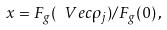<formula> <loc_0><loc_0><loc_500><loc_500>x = F _ { g } ( \ V e c { \rho } _ { j } ) / F _ { g } ( 0 ) \, ,</formula> 